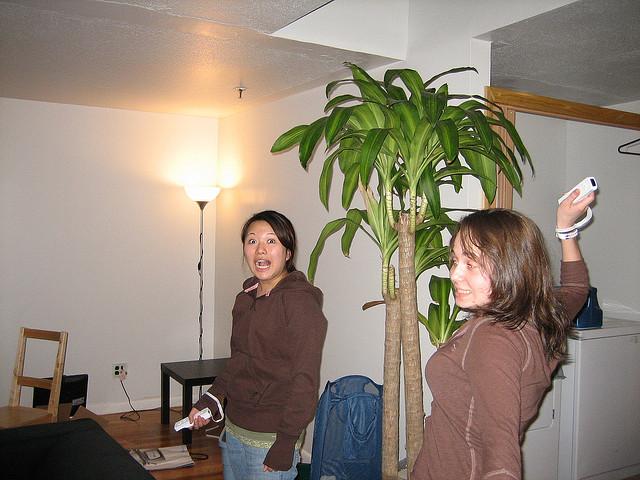Where are the flowers?
Answer briefly. Nowhere. Is the tree real?
Give a very brief answer. Yes. Is there a tree in the room?
Write a very short answer. Yes. What color is the wall in this photo?
Give a very brief answer. White. How many light bulbs are here?
Give a very brief answer. 1. Where is the lamp?
Answer briefly. Corner. Are the girls playing a Wii?
Answer briefly. Yes. 